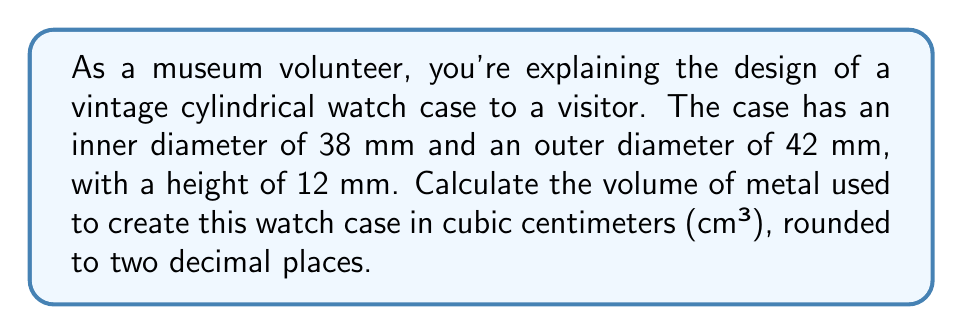Help me with this question. To solve this problem, we need to follow these steps:

1) First, we need to calculate the volume of the entire cylinder (including the hollow part):
   $$V_{total} = \pi r_{outer}^2 h$$
   Where $r_{outer}$ is the outer radius and $h$ is the height.

2) Then, we calculate the volume of the hollow part:
   $$V_{hollow} = \pi r_{inner}^2 h$$
   Where $r_{inner}$ is the inner radius.

3) The volume of metal used is the difference between these two volumes:
   $$V_{metal} = V_{total} - V_{hollow}$$

Let's plug in the values:

1) $r_{outer} = 42 \text{ mm} / 2 = 21 \text{ mm} = 2.1 \text{ cm}$
   $r_{inner} = 38 \text{ mm} / 2 = 19 \text{ mm} = 1.9 \text{ cm}$
   $h = 12 \text{ mm} = 1.2 \text{ cm}$

2) $V_{total} = \pi (2.1 \text{ cm})^2 (1.2 \text{ cm}) = 16.62 \text{ cm}^3$

3) $V_{hollow} = \pi (1.9 \text{ cm})^2 (1.2 \text{ cm}) = 13.61 \text{ cm}^3$

4) $V_{metal} = 16.62 \text{ cm}^3 - 13.61 \text{ cm}^3 = 3.01 \text{ cm}^3$

Rounding to two decimal places, we get 3.01 cm³.
Answer: $3.01 \text{ cm}^3$ 